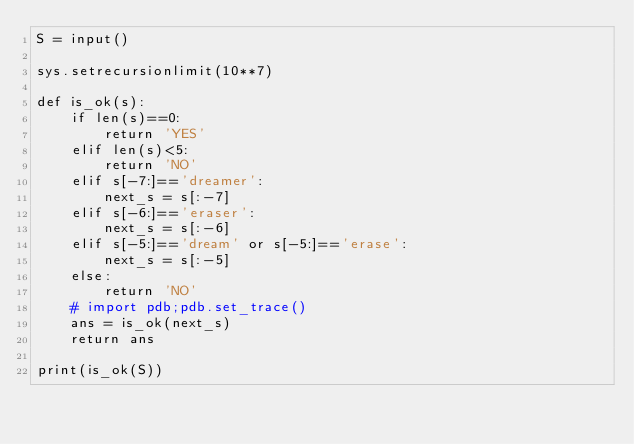<code> <loc_0><loc_0><loc_500><loc_500><_Python_>S = input()

sys.setrecursionlimit(10**7) 

def is_ok(s):
    if len(s)==0:
        return 'YES'
    elif len(s)<5:
        return 'NO'
    elif s[-7:]=='dreamer':
        next_s = s[:-7]
    elif s[-6:]=='eraser':
        next_s = s[:-6]
    elif s[-5:]=='dream' or s[-5:]=='erase':
        next_s = s[:-5]
    else:
        return 'NO'
    # import pdb;pdb.set_trace()
    ans = is_ok(next_s)
    return ans

print(is_ok(S))
</code> 